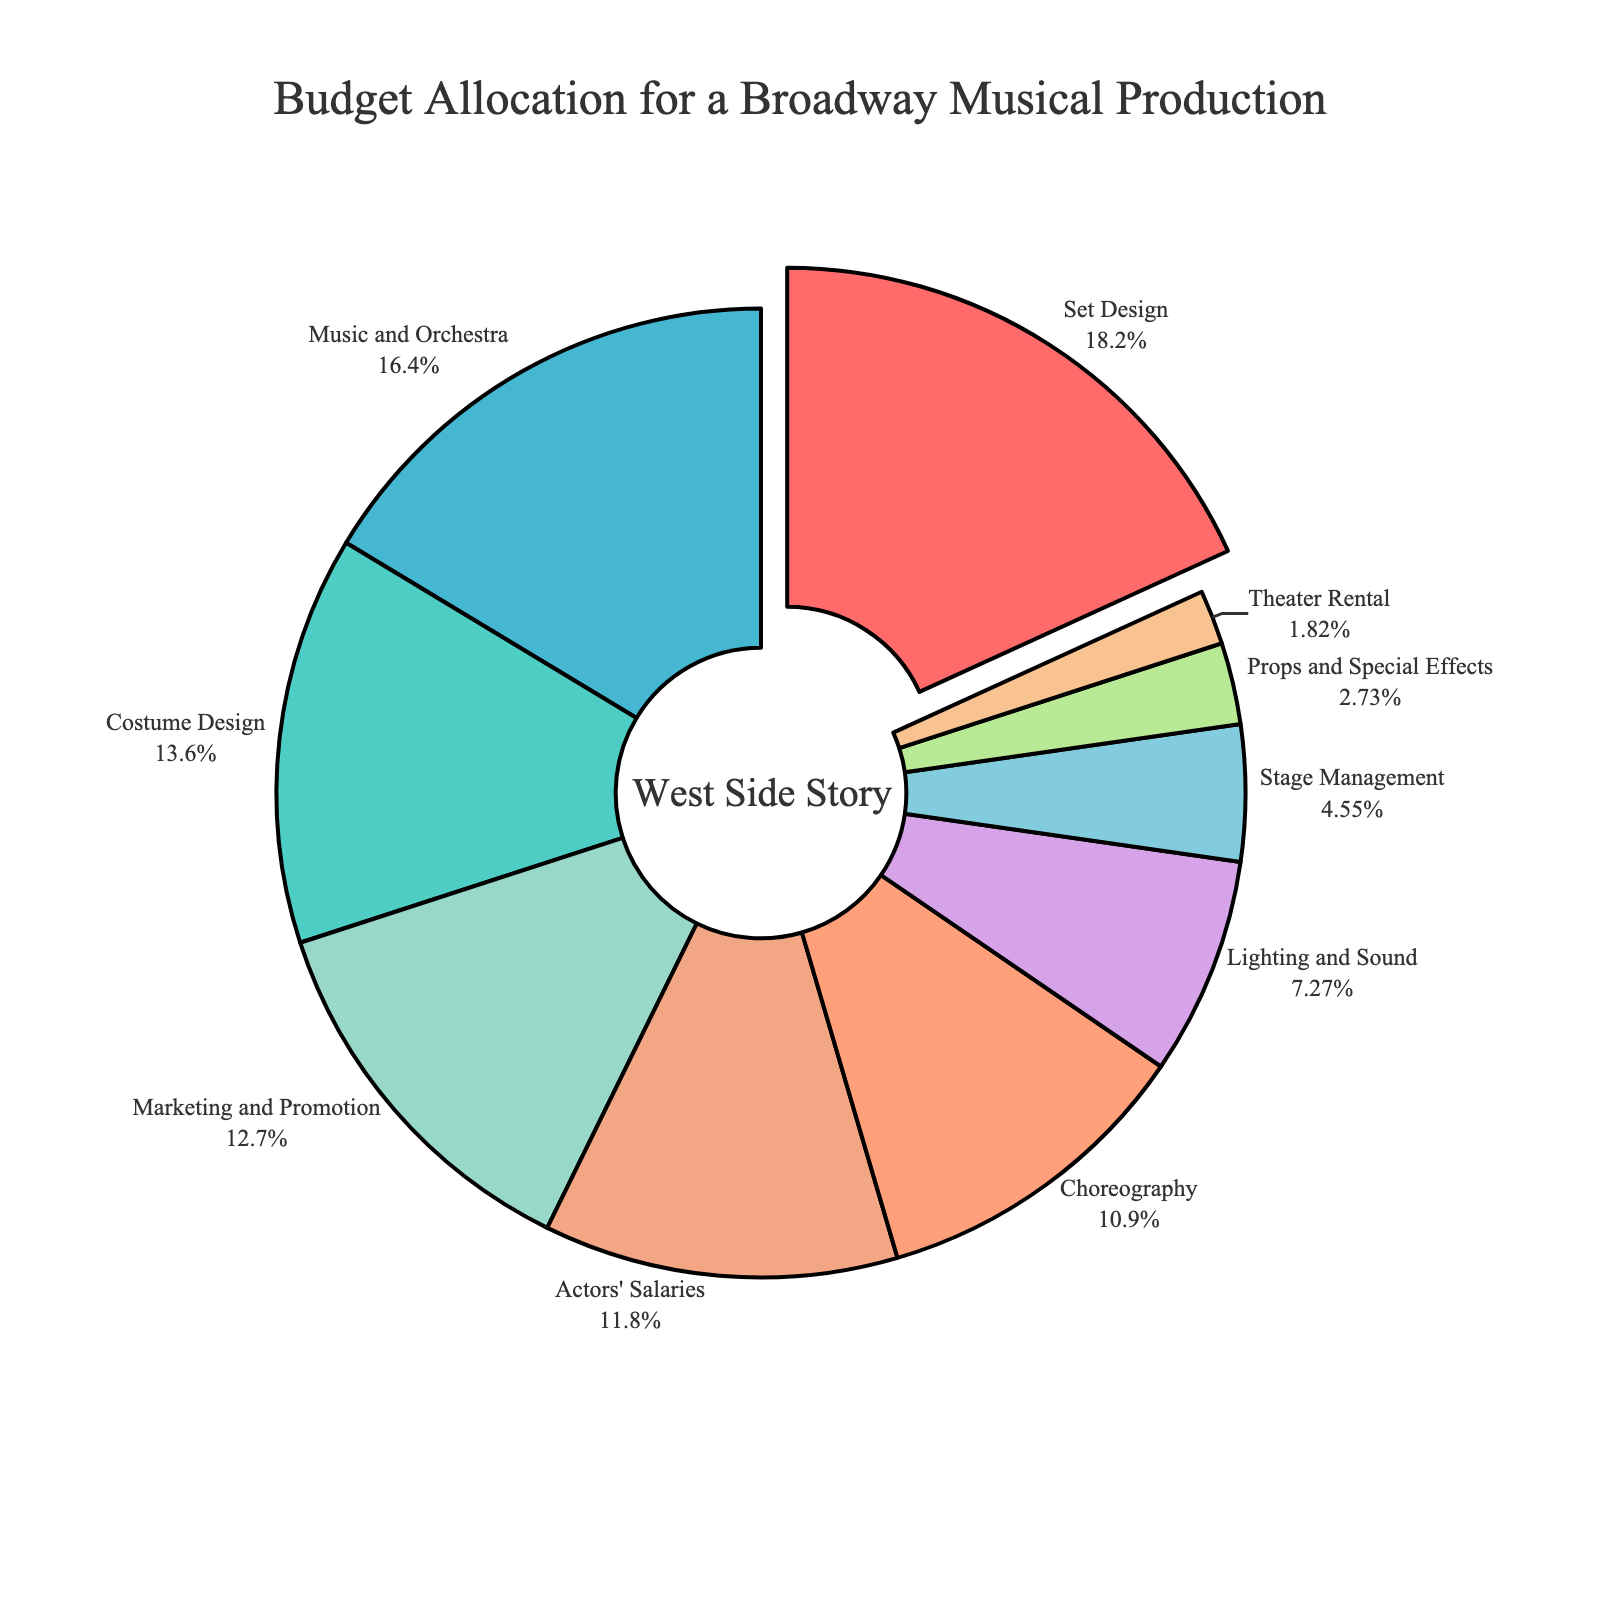Which department has the largest budget allocation? The largest segment in the pie chart reflects the department with the highest percentage. The segment for Set Design is the biggest.
Answer: Set Design How much more is allocated to Music and Orchestra than to Lighting and Sound? Music and Orchestra is given 18% of the budget, while Lighting and Sound has 8%. Subtracting these, 18 - 8 = 10%.
Answer: 10% What is the combined budget percentage for Set Design and Costume Design? Set Design is 20% and Costume Design is 15%. Their combined budget is 20 + 15 = 35%.
Answer: 35% Is Actors' Salaries' budget greater than or less than Marketing and Promotion’s budget? Actors' Salaries is 13% and Marketing and Promotion is 14%. Therefore, 13% is less than 14%.
Answer: Less than What is the smallest budget allocation and which department does it represent? The smallest segment on the pie chart corresponds to Theater Rental with 2%.
Answer: 2%, Theater Rental How does the budget for Choreography compare with that for Costume Design? Choreography has a 12% budget, whereas Costume Design has 15%. Therefore, 12% is less than 15%.
Answer: Less than If you combine the budgets for Props and Special Effects and Theater Rental, do they exceed the budget for Stage Management? Props and Special Effects have 3% and Theater Rental 2%, summing up to 3 + 2 = 5%. Stage Management is also allocated 5%. Therefore, they are equal.
Answer: Equal What percentage of the budget is allocated to departments related to visual production (Set Design, Costume Design, Props and Special Effects)? Set Design is 20%, Costume Design is 15%, and Props and Special Effects is 3%. Their combined budget is 20 + 15 + 3 = 38%.
Answer: 38% Given that the pie chart has annotations, what text is shown in the center? The annotation in the center of the pie chart says "West Side Story".
Answer: West Side Story Which department has a budget allocation closest to the average allocation for all departments? The total budget is 100%. There are 10 departments, so the average allocation is 100 / 10 = 10%. Lighting and Sound at 8% is the closest.
Answer: Lighting and Sound 